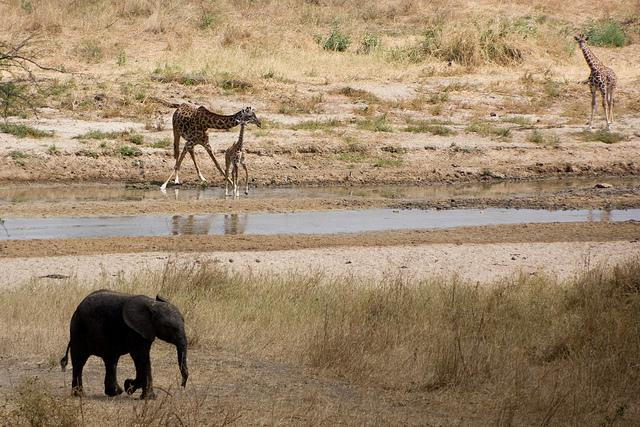Why does that animal have its legs spread? Please explain your reasoning. to drink. It's so it can lean down and reach the water easier 